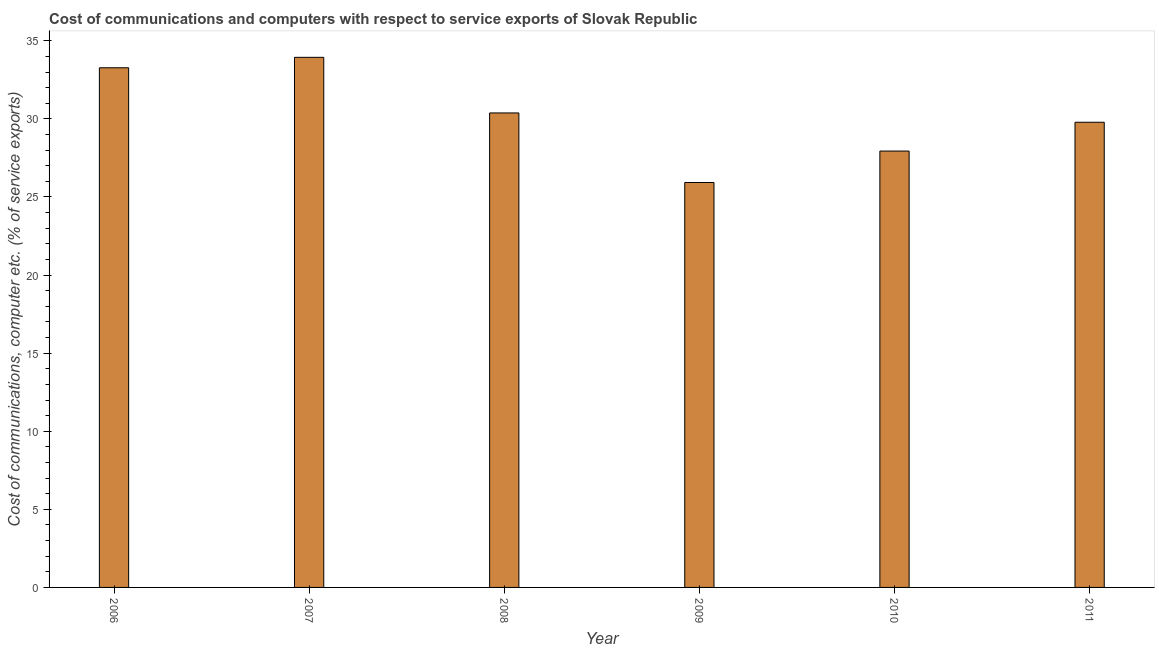Does the graph contain any zero values?
Keep it short and to the point. No. Does the graph contain grids?
Provide a succinct answer. No. What is the title of the graph?
Offer a very short reply. Cost of communications and computers with respect to service exports of Slovak Republic. What is the label or title of the X-axis?
Make the answer very short. Year. What is the label or title of the Y-axis?
Keep it short and to the point. Cost of communications, computer etc. (% of service exports). What is the cost of communications and computer in 2009?
Make the answer very short. 25.93. Across all years, what is the maximum cost of communications and computer?
Your answer should be compact. 33.94. Across all years, what is the minimum cost of communications and computer?
Make the answer very short. 25.93. What is the sum of the cost of communications and computer?
Make the answer very short. 181.24. What is the difference between the cost of communications and computer in 2006 and 2008?
Offer a terse response. 2.89. What is the average cost of communications and computer per year?
Provide a short and direct response. 30.21. What is the median cost of communications and computer?
Your response must be concise. 30.08. What is the ratio of the cost of communications and computer in 2008 to that in 2009?
Offer a very short reply. 1.17. Is the cost of communications and computer in 2007 less than that in 2008?
Keep it short and to the point. No. Is the difference between the cost of communications and computer in 2007 and 2010 greater than the difference between any two years?
Make the answer very short. No. What is the difference between the highest and the second highest cost of communications and computer?
Offer a very short reply. 0.67. Is the sum of the cost of communications and computer in 2009 and 2010 greater than the maximum cost of communications and computer across all years?
Offer a very short reply. Yes. What is the difference between the highest and the lowest cost of communications and computer?
Offer a very short reply. 8.01. In how many years, is the cost of communications and computer greater than the average cost of communications and computer taken over all years?
Make the answer very short. 3. How many bars are there?
Provide a succinct answer. 6. What is the Cost of communications, computer etc. (% of service exports) in 2006?
Keep it short and to the point. 33.27. What is the Cost of communications, computer etc. (% of service exports) in 2007?
Offer a terse response. 33.94. What is the Cost of communications, computer etc. (% of service exports) of 2008?
Offer a terse response. 30.38. What is the Cost of communications, computer etc. (% of service exports) of 2009?
Give a very brief answer. 25.93. What is the Cost of communications, computer etc. (% of service exports) in 2010?
Your answer should be compact. 27.94. What is the Cost of communications, computer etc. (% of service exports) of 2011?
Provide a short and direct response. 29.78. What is the difference between the Cost of communications, computer etc. (% of service exports) in 2006 and 2007?
Give a very brief answer. -0.67. What is the difference between the Cost of communications, computer etc. (% of service exports) in 2006 and 2008?
Provide a short and direct response. 2.89. What is the difference between the Cost of communications, computer etc. (% of service exports) in 2006 and 2009?
Your answer should be very brief. 7.35. What is the difference between the Cost of communications, computer etc. (% of service exports) in 2006 and 2010?
Provide a short and direct response. 5.33. What is the difference between the Cost of communications, computer etc. (% of service exports) in 2006 and 2011?
Keep it short and to the point. 3.49. What is the difference between the Cost of communications, computer etc. (% of service exports) in 2007 and 2008?
Ensure brevity in your answer.  3.56. What is the difference between the Cost of communications, computer etc. (% of service exports) in 2007 and 2009?
Ensure brevity in your answer.  8.01. What is the difference between the Cost of communications, computer etc. (% of service exports) in 2007 and 2010?
Ensure brevity in your answer.  6. What is the difference between the Cost of communications, computer etc. (% of service exports) in 2007 and 2011?
Keep it short and to the point. 4.16. What is the difference between the Cost of communications, computer etc. (% of service exports) in 2008 and 2009?
Make the answer very short. 4.45. What is the difference between the Cost of communications, computer etc. (% of service exports) in 2008 and 2010?
Provide a succinct answer. 2.44. What is the difference between the Cost of communications, computer etc. (% of service exports) in 2008 and 2011?
Your answer should be compact. 0.6. What is the difference between the Cost of communications, computer etc. (% of service exports) in 2009 and 2010?
Offer a terse response. -2.01. What is the difference between the Cost of communications, computer etc. (% of service exports) in 2009 and 2011?
Make the answer very short. -3.86. What is the difference between the Cost of communications, computer etc. (% of service exports) in 2010 and 2011?
Your response must be concise. -1.84. What is the ratio of the Cost of communications, computer etc. (% of service exports) in 2006 to that in 2007?
Keep it short and to the point. 0.98. What is the ratio of the Cost of communications, computer etc. (% of service exports) in 2006 to that in 2008?
Your answer should be very brief. 1.09. What is the ratio of the Cost of communications, computer etc. (% of service exports) in 2006 to that in 2009?
Your answer should be compact. 1.28. What is the ratio of the Cost of communications, computer etc. (% of service exports) in 2006 to that in 2010?
Give a very brief answer. 1.19. What is the ratio of the Cost of communications, computer etc. (% of service exports) in 2006 to that in 2011?
Your answer should be very brief. 1.12. What is the ratio of the Cost of communications, computer etc. (% of service exports) in 2007 to that in 2008?
Your answer should be compact. 1.12. What is the ratio of the Cost of communications, computer etc. (% of service exports) in 2007 to that in 2009?
Your response must be concise. 1.31. What is the ratio of the Cost of communications, computer etc. (% of service exports) in 2007 to that in 2010?
Provide a succinct answer. 1.22. What is the ratio of the Cost of communications, computer etc. (% of service exports) in 2007 to that in 2011?
Offer a terse response. 1.14. What is the ratio of the Cost of communications, computer etc. (% of service exports) in 2008 to that in 2009?
Make the answer very short. 1.17. What is the ratio of the Cost of communications, computer etc. (% of service exports) in 2008 to that in 2010?
Provide a succinct answer. 1.09. What is the ratio of the Cost of communications, computer etc. (% of service exports) in 2009 to that in 2010?
Provide a succinct answer. 0.93. What is the ratio of the Cost of communications, computer etc. (% of service exports) in 2009 to that in 2011?
Make the answer very short. 0.87. What is the ratio of the Cost of communications, computer etc. (% of service exports) in 2010 to that in 2011?
Give a very brief answer. 0.94. 